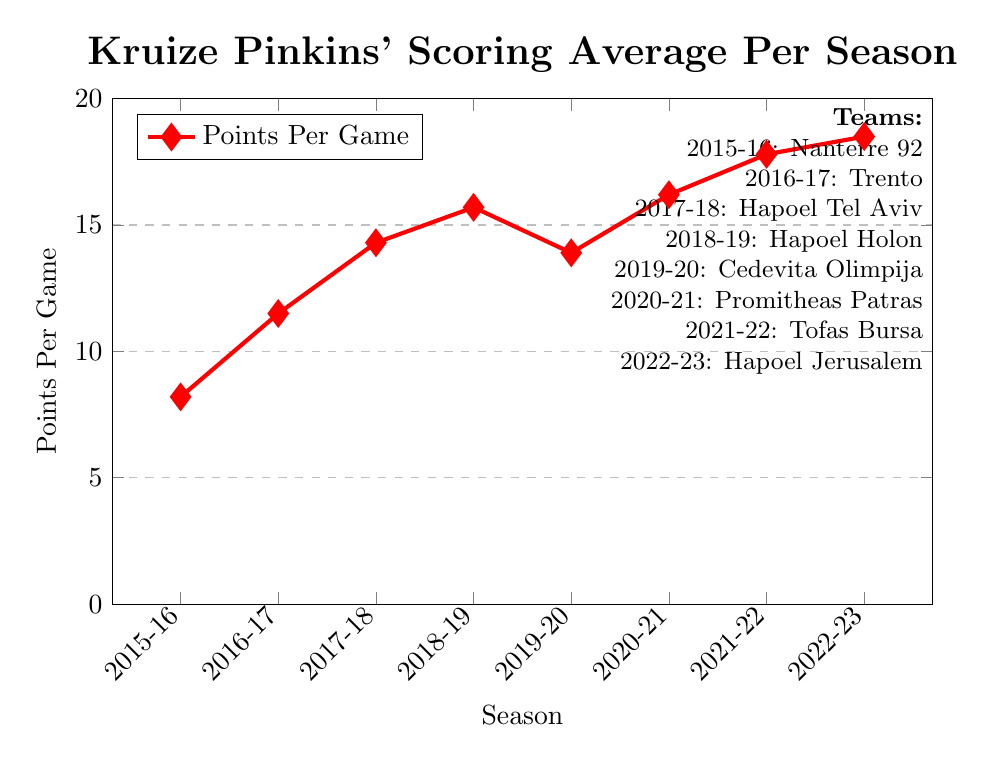What was Kruize Pinkins' scoring average for the 2015-16 season? Look at the point on the line chart corresponding to the 2015-16 season. The value is 8.2 points per game.
Answer: 8.2 Which team did Kruize Pinkins score the highest average points per game with? Identify the peak of the line chart and see which season it corresponds to. The highest value is 18.5 points per game in the 2022-23 season with Hapoel Jerusalem.
Answer: Hapoel Jerusalem How many seasons did Kruize Pinkins' scoring average increase consecutively? Observe the trend in the line chart, and count consecutive seasons where the average increased: from 2015-16 to 2018-19 (3 seasons) and from 2019-20 to 2022-23 (3 seasons).
Answer: 3 seasons twice What is the difference in scoring average between the 2018-19 and 2019-20 seasons? Find the values for the 2018-19 season (15.7) and 2019-20 season (13.9). Subtract the latter from the former: 15.7 - 13.9 = 1.8 points per game.
Answer: 1.8 During which season did Kruize Pinkins experience the highest increase in scoring average compared to the previous season? Compare the differences between consecutive seasons: 
2015-16 to 2016-17: 11.5 - 8.2 = 3.3
2016-17 to 2017-18: 14.3 - 11.5 = 2.8
2017-18 to 2018-19: 15.7 - 14.3 = 1.4
2018-19 to 2019-20: 13.9 - 15.7 = -1.8
2019-20 to 2020-21: 16.2 - 13.9 = 2.3
2020-21 to 2021-22: 17.8 - 16.2 = 1.6
2021-22 to 2022-23: 18.5 - 17.8 = 0.7
The highest increase is 3.3 (2015-16 to 2016-17).
Answer: 2016-17 What's the average scoring average per season from 2015-16 to 2018-19? Sum the scoring averages from 2015-16 to 2018-19, then divide by the number of seasons. (8.2 + 11.5 + 14.3 + 15.7) / 4 = 12.425
Answer: 12.425 How did Kruize Pinkins' scoring average change after joining Cedevita Olimpija compared to his previous team? Compare the 2018-19 and 2019-20 seasons. The scoring average dropped from 15.7 to 13.9, a decrease of 1.8 points per game.
Answer: Decreased by 1.8 If you average Kruize Pinkins' points per game for the seasons with Hapoel Tel Aviv, Hapoel Holon, and Hapoel Jerusalem, what is the result? Calculate the values for the respective seasons: (14.3 + 15.7 + 18.5) / 3 = 16.167
Answer: 16.167 Which season had a higher scoring average, 2020-21 or 2021-22? Compare the points per game for the two seasons: 2020-21 (16.2) and 2021-22 (17.8). 2021-22 has a higher average.
Answer: 2021-22 In which seasons did Kruize Pinkins play for Israeli teams, and what were his scoring averages for those seasons? Identify the Israeli teams from the chart and corresponding seasons: Hapoel Tel Aviv (2017-18, 14.3), Hapoel Holon (2018-19, 15.7), and Hapoel Jerusalem (2022-23, 18.5).
Answer: 2017-18 (14.3), 2018-19 (15.7), 2022-23 (18.5) 